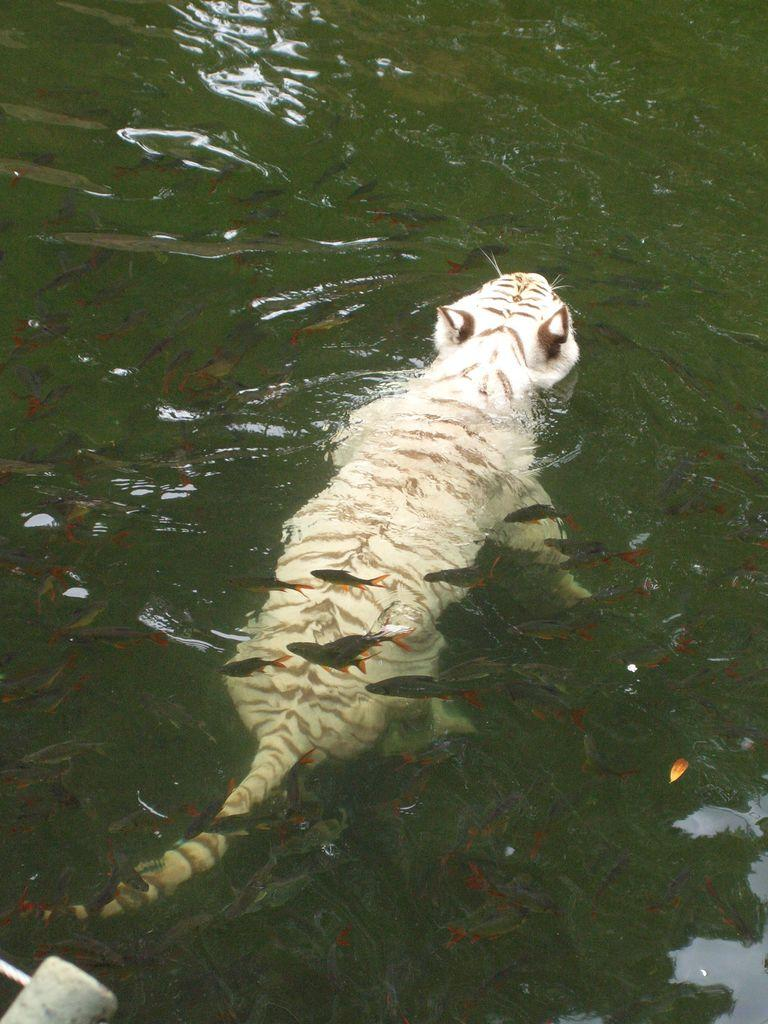What animal is in the image? There is a tiger in the image. Where is the tiger located? The tiger is in the water. What else can be seen in the water with the tiger? There are fish in the water. What type of airplane can be seen flying over the tiger in the image? There is no airplane present in the image; it only features a tiger in the water with fish. 